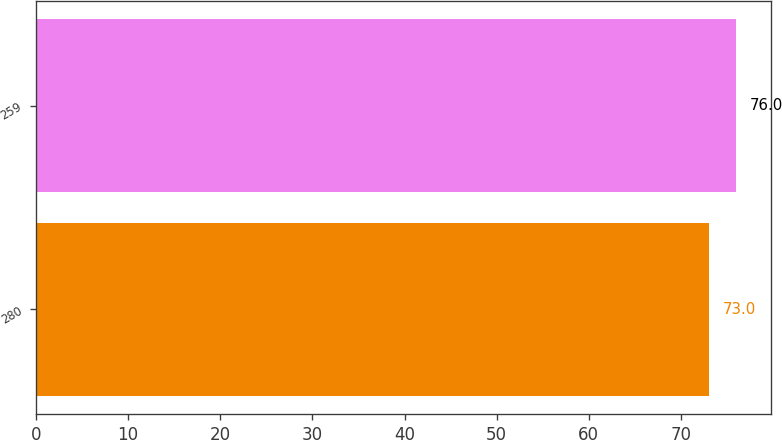Convert chart to OTSL. <chart><loc_0><loc_0><loc_500><loc_500><bar_chart><fcel>280<fcel>259<nl><fcel>73<fcel>76<nl></chart> 